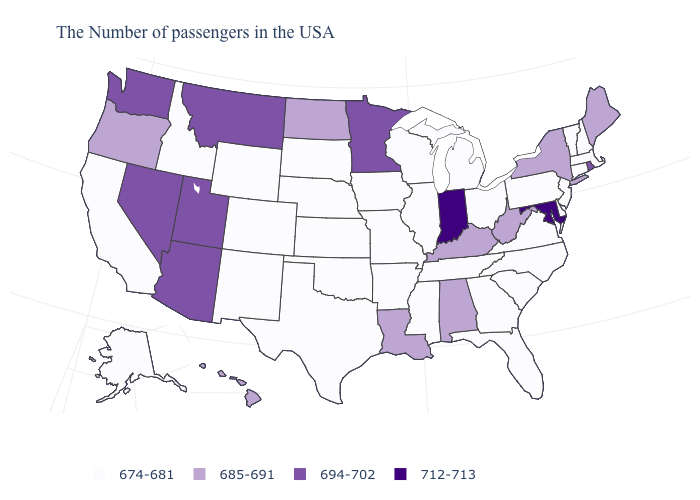Name the states that have a value in the range 674-681?
Give a very brief answer. Massachusetts, New Hampshire, Vermont, Connecticut, New Jersey, Delaware, Pennsylvania, Virginia, North Carolina, South Carolina, Ohio, Florida, Georgia, Michigan, Tennessee, Wisconsin, Illinois, Mississippi, Missouri, Arkansas, Iowa, Kansas, Nebraska, Oklahoma, Texas, South Dakota, Wyoming, Colorado, New Mexico, Idaho, California, Alaska. Name the states that have a value in the range 685-691?
Quick response, please. Maine, New York, West Virginia, Kentucky, Alabama, Louisiana, North Dakota, Oregon, Hawaii. What is the value of Oregon?
Write a very short answer. 685-691. Does Iowa have a lower value than Oregon?
Give a very brief answer. Yes. What is the highest value in the MidWest ?
Answer briefly. 712-713. Does the first symbol in the legend represent the smallest category?
Give a very brief answer. Yes. Which states hav the highest value in the West?
Concise answer only. Utah, Montana, Arizona, Nevada, Washington. Does Arizona have the same value as Delaware?
Concise answer only. No. Does the first symbol in the legend represent the smallest category?
Write a very short answer. Yes. Name the states that have a value in the range 712-713?
Keep it brief. Maryland, Indiana. Name the states that have a value in the range 674-681?
Keep it brief. Massachusetts, New Hampshire, Vermont, Connecticut, New Jersey, Delaware, Pennsylvania, Virginia, North Carolina, South Carolina, Ohio, Florida, Georgia, Michigan, Tennessee, Wisconsin, Illinois, Mississippi, Missouri, Arkansas, Iowa, Kansas, Nebraska, Oklahoma, Texas, South Dakota, Wyoming, Colorado, New Mexico, Idaho, California, Alaska. Which states have the lowest value in the Northeast?
Short answer required. Massachusetts, New Hampshire, Vermont, Connecticut, New Jersey, Pennsylvania. Does the map have missing data?
Write a very short answer. No. Among the states that border Kansas , which have the lowest value?
Answer briefly. Missouri, Nebraska, Oklahoma, Colorado. 